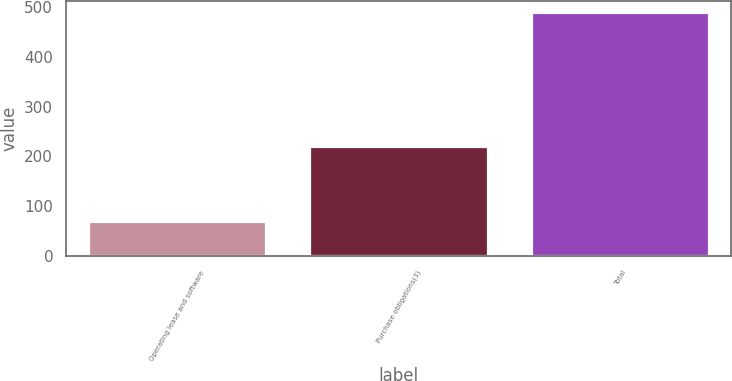Convert chart to OTSL. <chart><loc_0><loc_0><loc_500><loc_500><bar_chart><fcel>Operating lease and software<fcel>Purchase obligations(3)<fcel>Total<nl><fcel>68.9<fcel>219.5<fcel>488.4<nl></chart> 